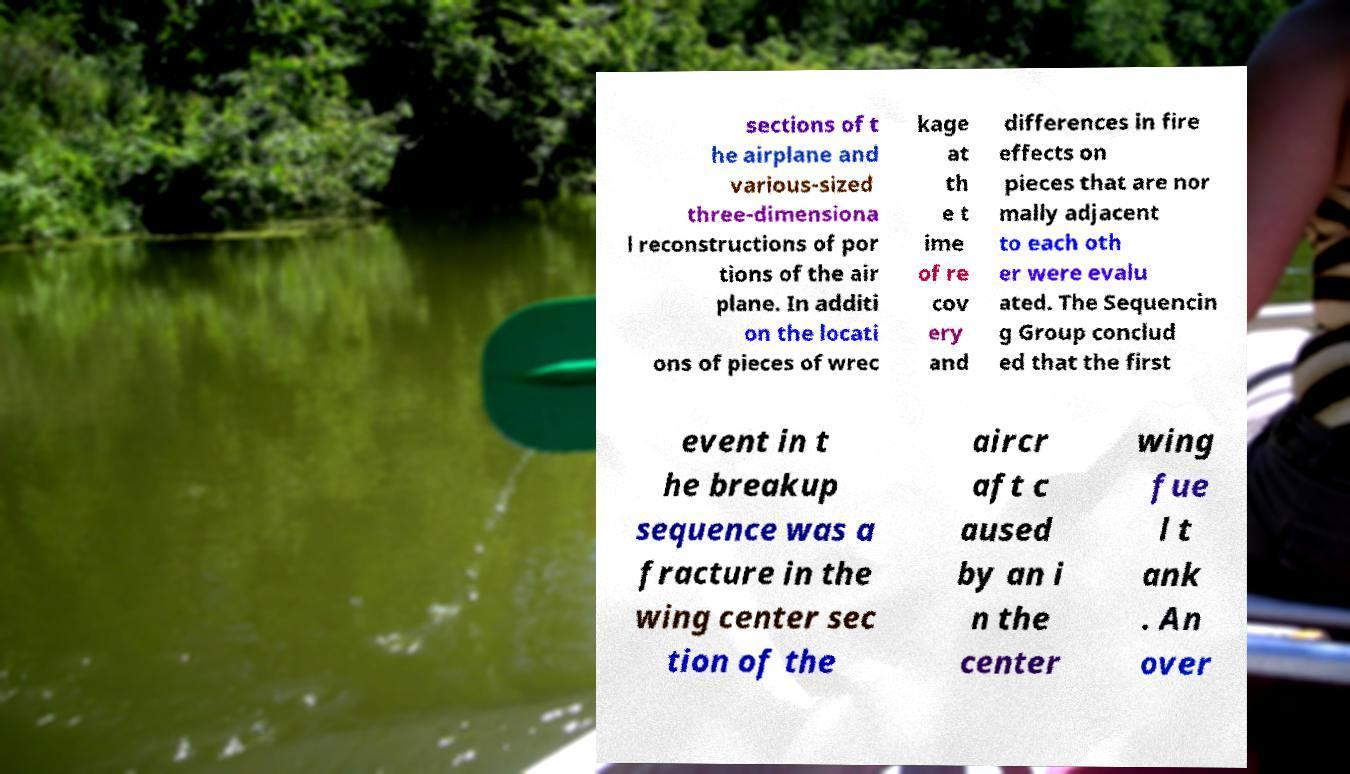Can you accurately transcribe the text from the provided image for me? sections of t he airplane and various-sized three-dimensiona l reconstructions of por tions of the air plane. In additi on the locati ons of pieces of wrec kage at th e t ime of re cov ery and differences in fire effects on pieces that are nor mally adjacent to each oth er were evalu ated. The Sequencin g Group conclud ed that the first event in t he breakup sequence was a fracture in the wing center sec tion of the aircr aft c aused by an i n the center wing fue l t ank . An over 